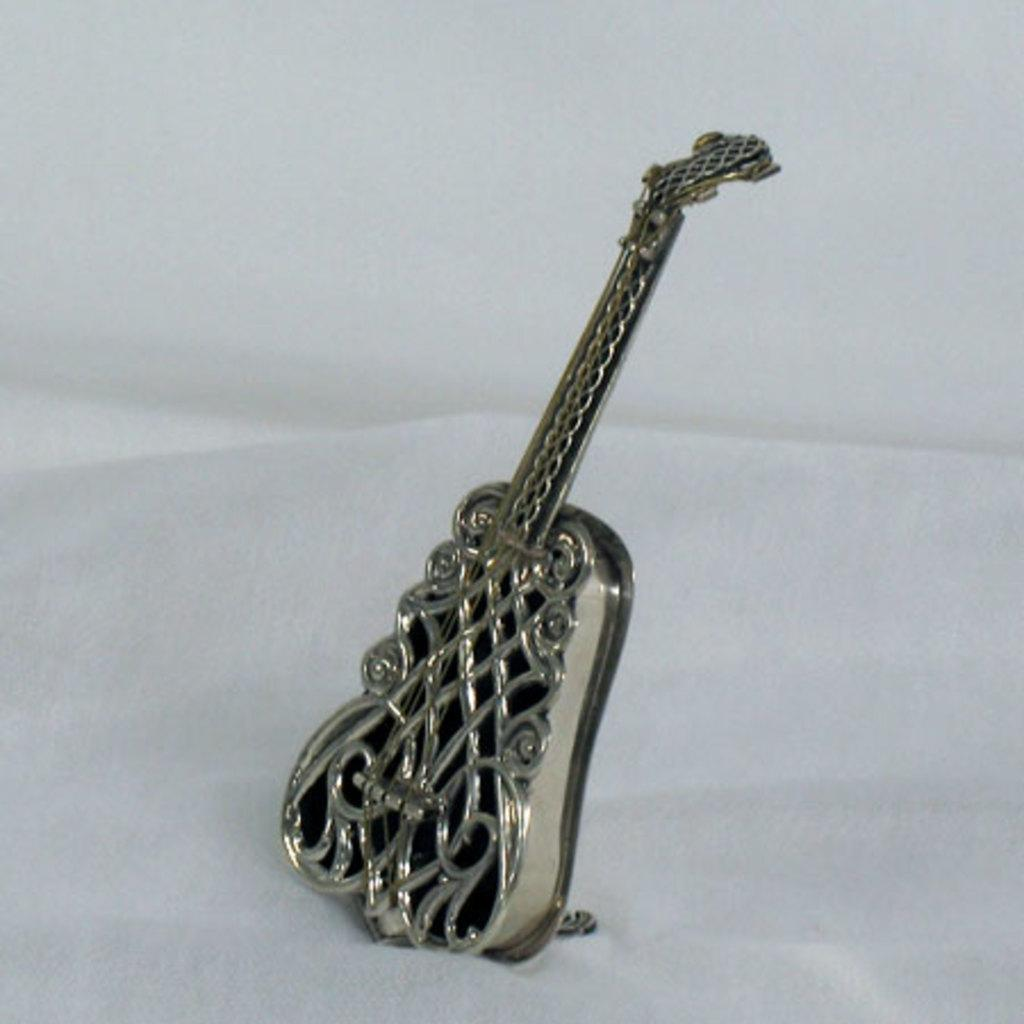What musical instrument is present in the image? There is a guitar in the image. What is the guitar placed on? The guitar is on a white surface. What color is the background of the image? The background of the image is white. What type of jewel is being used to tune the guitar in the image? There is no jewel present in the image, and the guitar is not being tuned. 